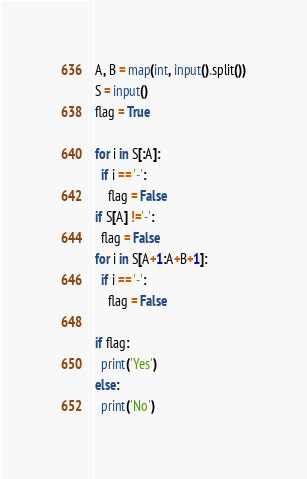Convert code to text. <code><loc_0><loc_0><loc_500><loc_500><_Python_>A, B = map(int, input().split())
S = input()
flag = True

for i in S[:A]:
  if i == '-':
    flag = False
if S[A] !='-':
  flag = False
for i in S[A+1:A+B+1]:
  if i == '-':
    flag = False
   
if flag:
  print('Yes')
else:
  print('No')
</code> 